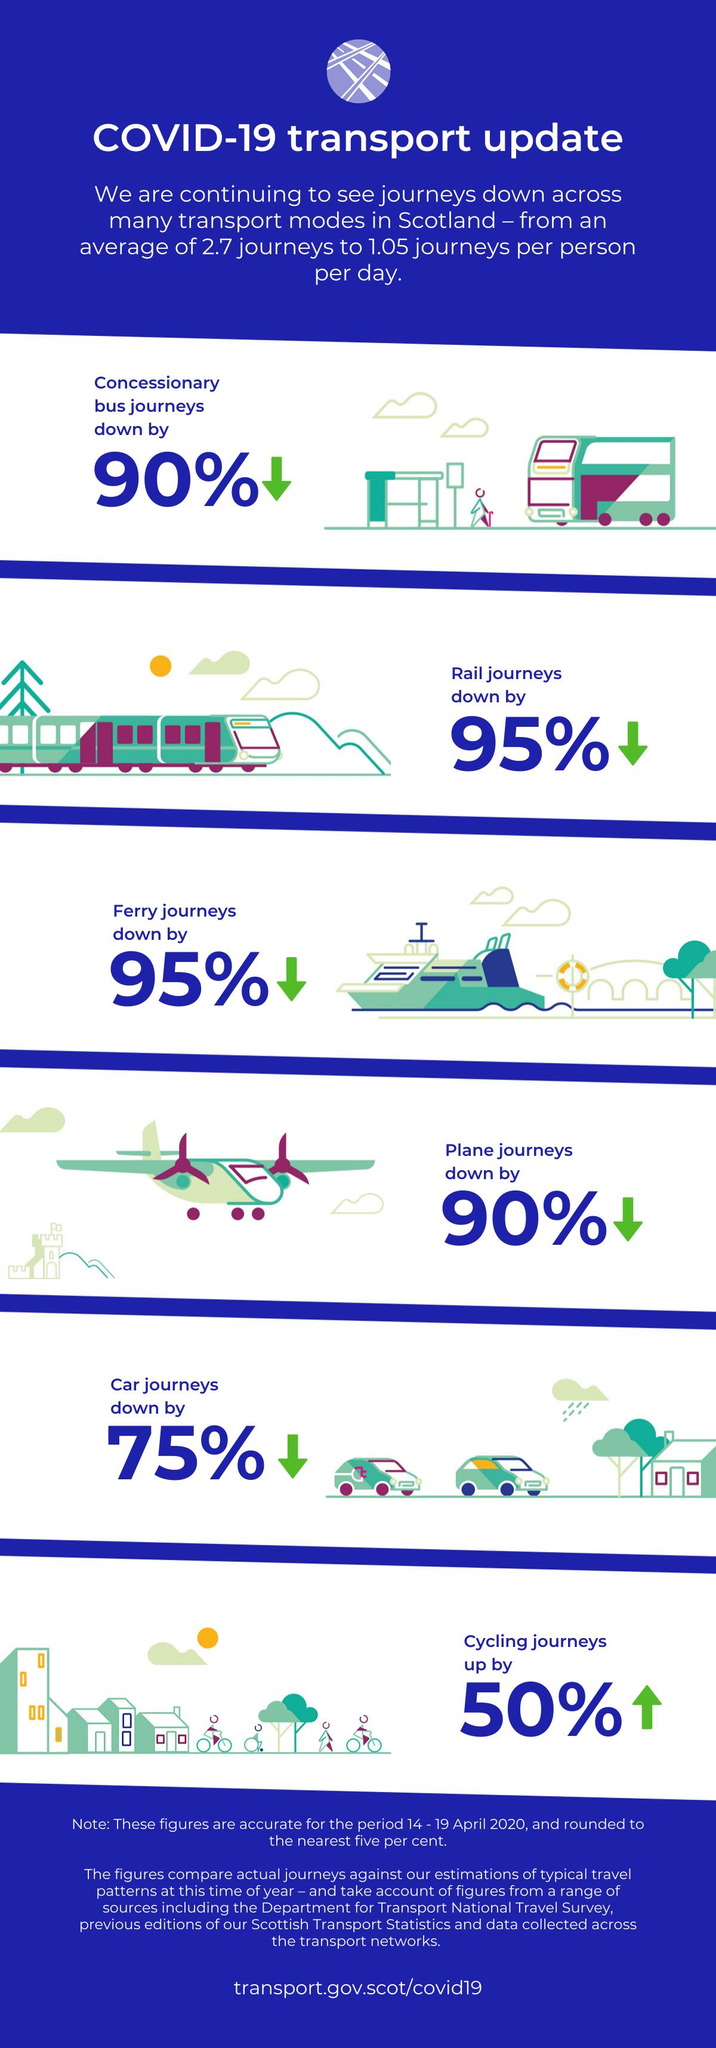Draw attention to some important aspects in this diagram. In this infographic, the different types of road transport are depicted as bus, car, and cycling. 